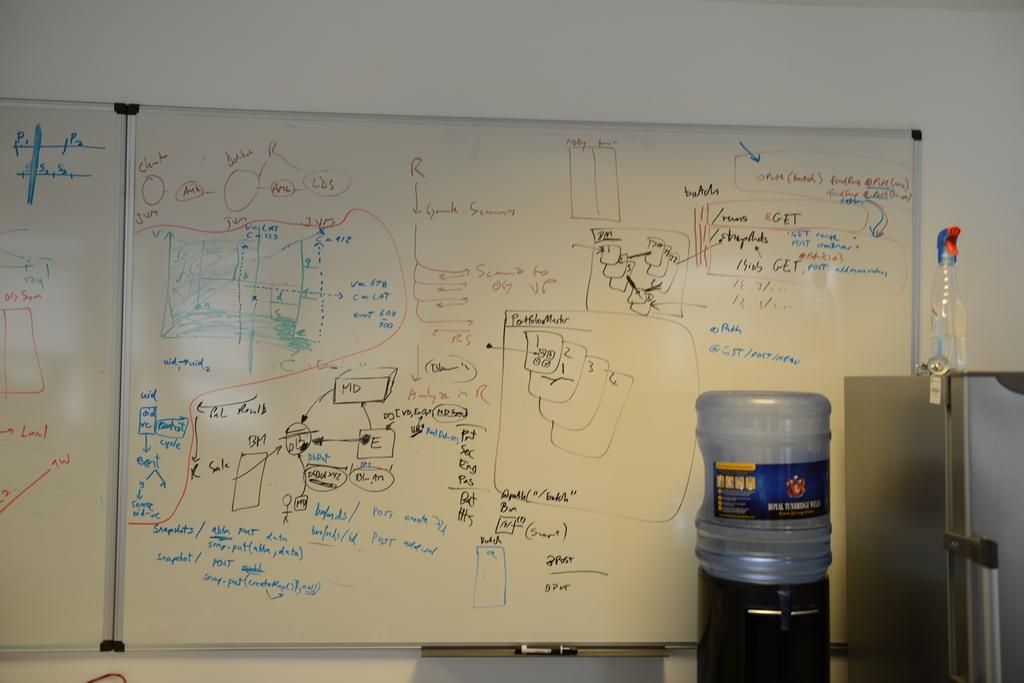What is on the wall in the image? There is a board on the wall with a note. What is in front of the board on the wall? There is a fridge in front of the board. What is on top of the fridge? There is a bottle on the fridge. What is located beside the fridge? There is a water tank beside the fridge. How many pairs of shoes are visible in the image? There are no shoes visible in the image. What type of government is depicted in the note on the board? The note on the board does not mention any type of government; it is not present in the image. 